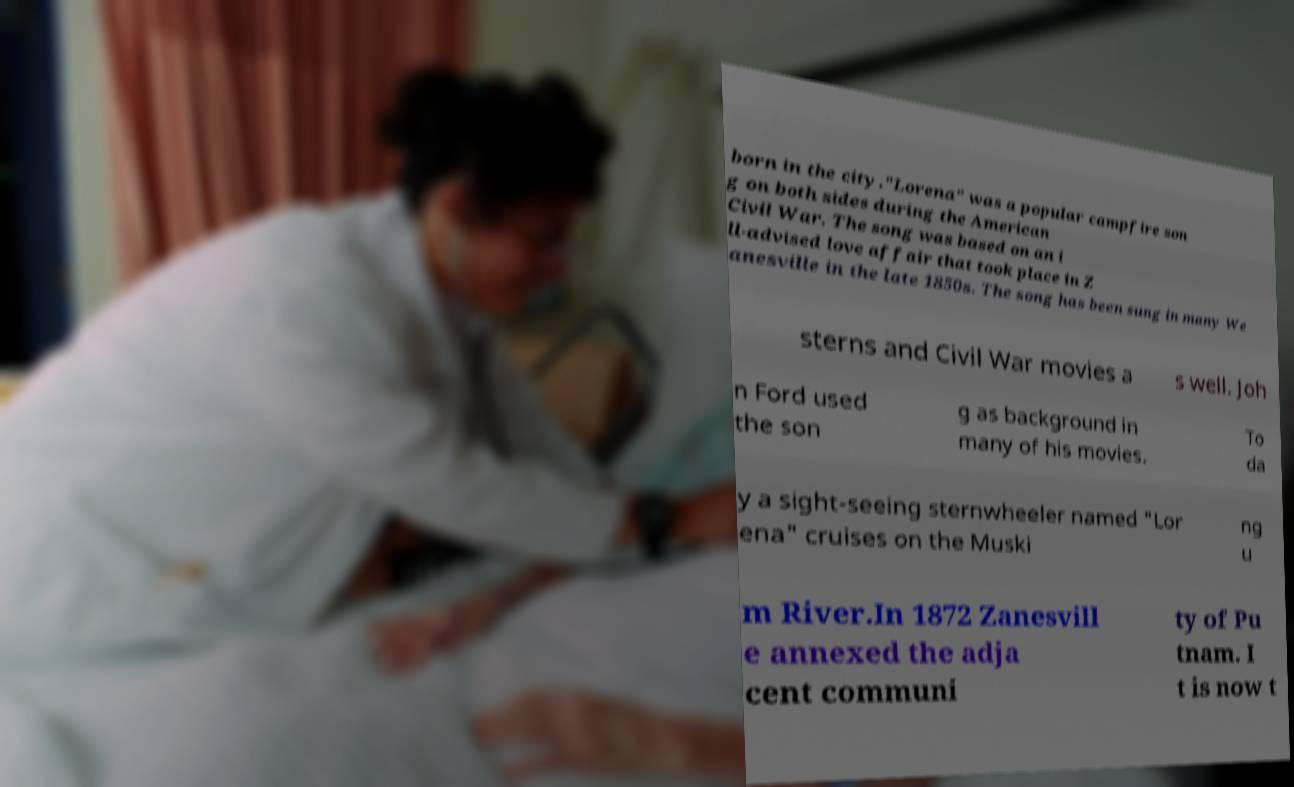Could you extract and type out the text from this image? born in the city."Lorena" was a popular campfire son g on both sides during the American Civil War. The song was based on an i ll-advised love affair that took place in Z anesville in the late 1850s. The song has been sung in many We sterns and Civil War movies a s well. Joh n Ford used the son g as background in many of his movies. To da y a sight-seeing sternwheeler named "Lor ena" cruises on the Muski ng u m River.In 1872 Zanesvill e annexed the adja cent communi ty of Pu tnam. I t is now t 